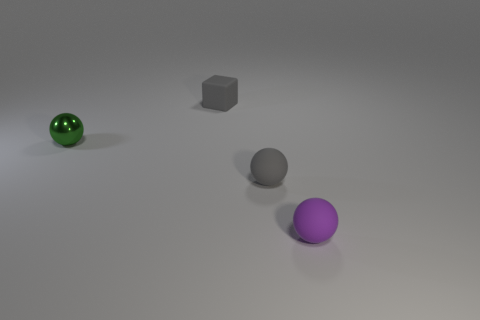Can you describe the shapes and colors of the objects in the image? Certainly! There are three prominent objects in the image. On the left, there's a small, shiny, green sphere. In the center, we see a medium-sized, matte grey cube. Lastly, on the right, there's a larger, purple sphere with what seems to be a rubber texture. What could be the context or the purpose of arranging these objects like this? This arrangement may be for a visual composition designed to study or demonstrate various geometric shapes, textures, and colors. The contrasts and spacing also suggest an exercise in 3D rendering or possibly a setup for a basic physics simulation. 